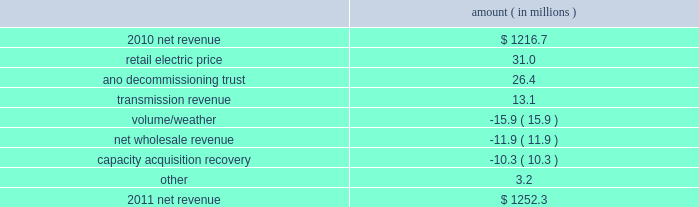Entergy arkansas , inc .
And subsidiaries management 2019s financial discussion and analysis plan to spin off the utility 2019s transmission business see the 201cplan to spin off the utility 2019s transmission business 201d section of entergy corporation and subsidiaries management 2019s financial discussion and analysis for a discussion of this matter , including the planned retirement of debt and preferred securities .
Results of operations net income 2011 compared to 2010 net income decreased $ 7.7 million primarily due to a higher effective income tax rate , lower other income , and higher other operation and maintenance expenses , substantially offset by higher net revenue , lower depreciation and amortization expenses , and lower interest expense .
2010 compared to 2009 net income increased $ 105.7 million primarily due to higher net revenue , a lower effective income tax rate , higher other income , and lower depreciation and amortization expenses , partially offset by higher other operation and maintenance expenses .
Net revenue 2011 compared to 2010 net revenue consists of operating revenues net of : 1 ) fuel , fuel-related expenses , and gas purchased for resale , 2 ) purchased power expenses , and 3 ) other regulatory charges ( credits ) .
Following is an analysis of the change in net revenue comparing 2011 to 2010 .
Amount ( in millions ) .
The retail electric price variance is primarily due to a base rate increase effective july 2010 .
See note 2 to the financial statements for more discussion of the rate case settlement .
The ano decommissioning trust variance is primarily related to the deferral of investment gains from the ano 1 and 2 decommissioning trust in 2010 in accordance with regulatory treatment .
The gains resulted in an increase in 2010 in interest and investment income and a corresponding increase in regulatory charges with no effect on net income. .
From the increase in net revenue , what percentage is attributed to the change in retail electric price? 
Computations: (31.0 / (1252.3 - 1216.7))
Answer: 0.87079. 